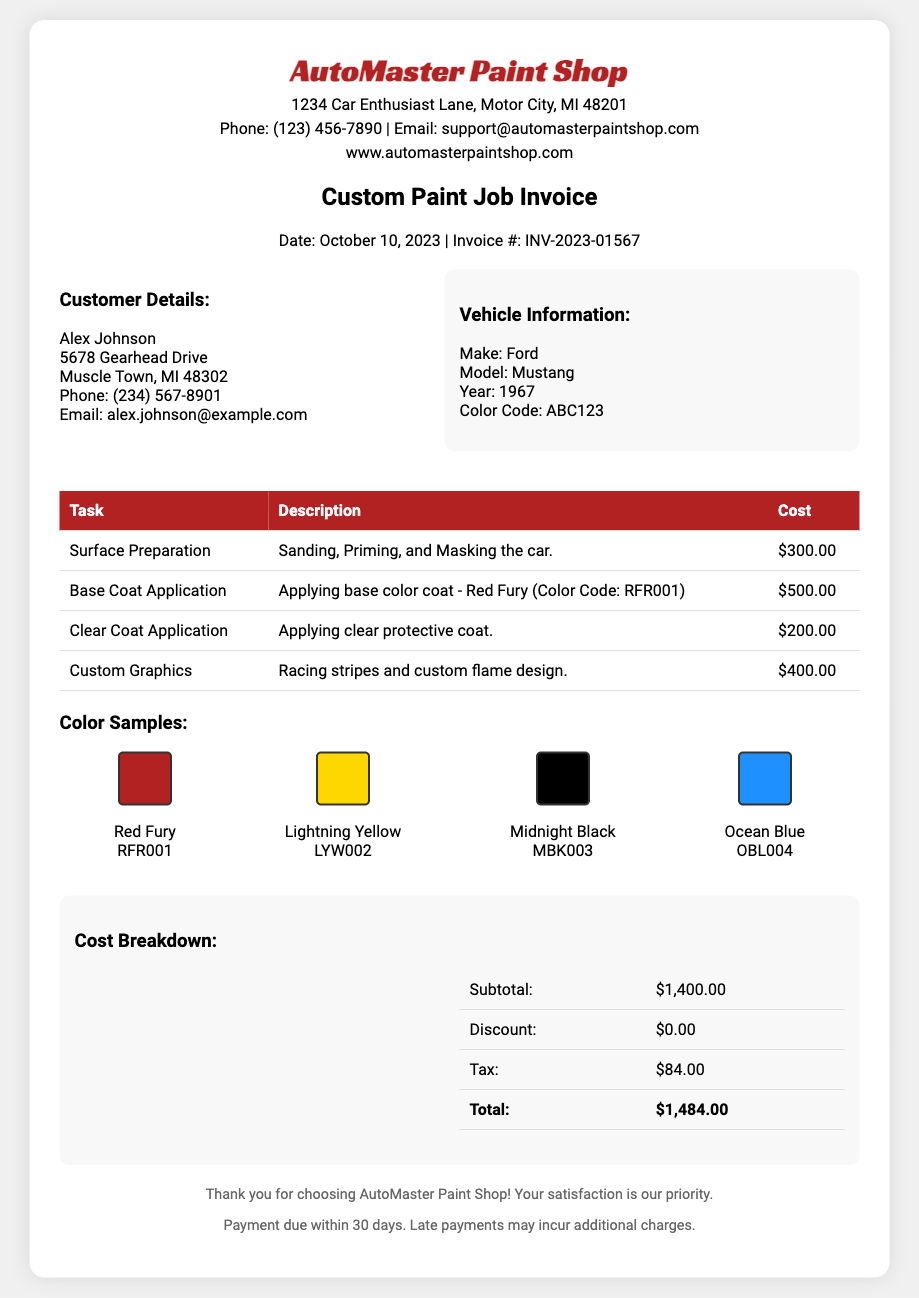What is the name of the paint shop? The name of the paint shop is clearly mentioned in the document header.
Answer: AutoMaster Paint Shop What is the invoice number? The invoice number can be found in the invoice details at the top of the document.
Answer: INV-2023-01567 What is the date of the invoice? The date is stated in the header section of the invoice details.
Answer: October 10, 2023 What is the cost for surface preparation? The cost for surface preparation is detailed in the task table of the invoice.
Answer: $300.00 What is the total amount due? The total amount can be found in the cost breakdown section of the invoice.
Answer: $1,484.00 What vehicle model is listed? The vehicle model can be found in the vehicle information section of the document.
Answer: Mustang How many color samples are provided? By counting the displayed color samples in the document, we can determine this information.
Answer: 4 What is the tax amount? The tax amount is specified in the cost breakdown section of the document.
Answer: $84.00 What is the name of the customer? The customer's name is provided in the customer details section of the document.
Answer: Alex Johnson 